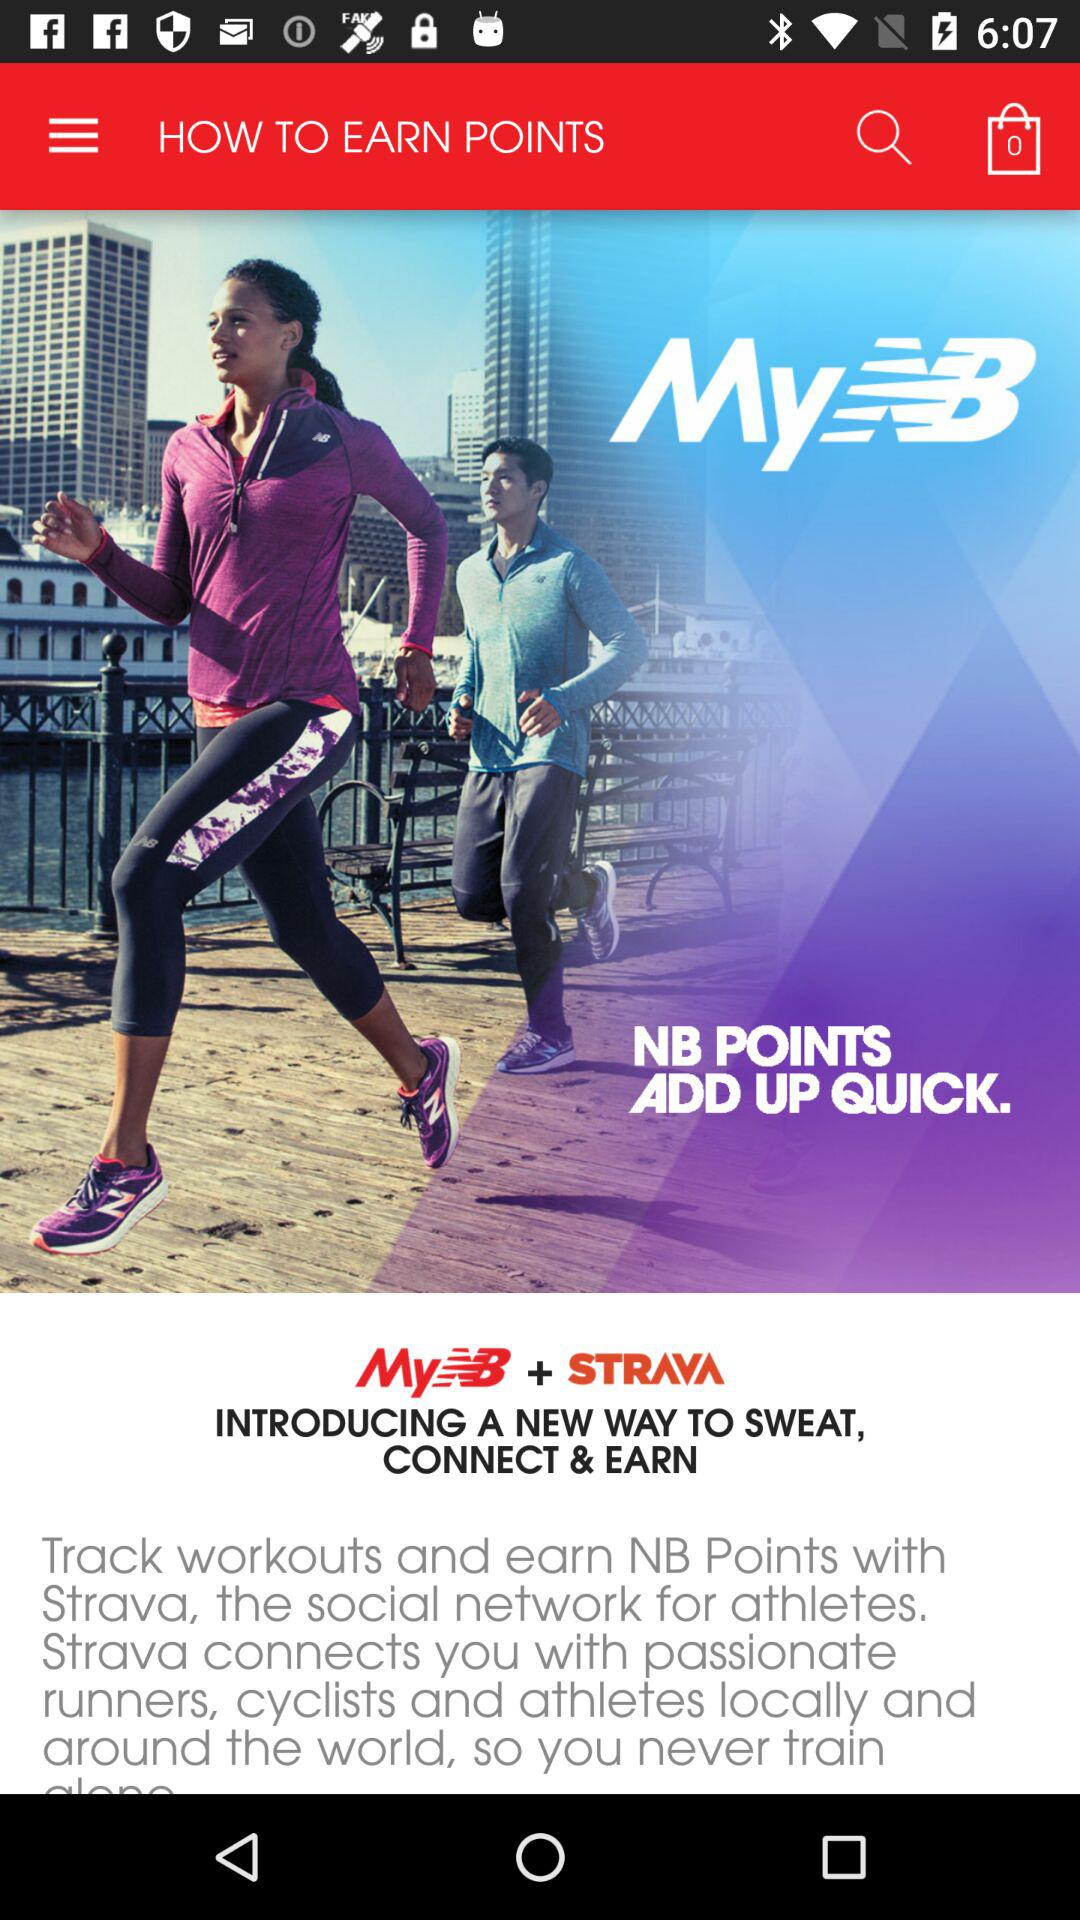How many items are there in the cart? There are 0 items in the cart. 